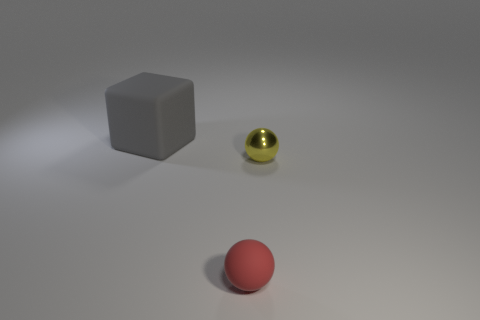Add 1 gray blocks. How many objects exist? 4 Subtract all blocks. How many objects are left? 2 Subtract all tiny red balls. Subtract all small balls. How many objects are left? 0 Add 2 big blocks. How many big blocks are left? 3 Add 2 matte things. How many matte things exist? 4 Subtract 1 yellow balls. How many objects are left? 2 